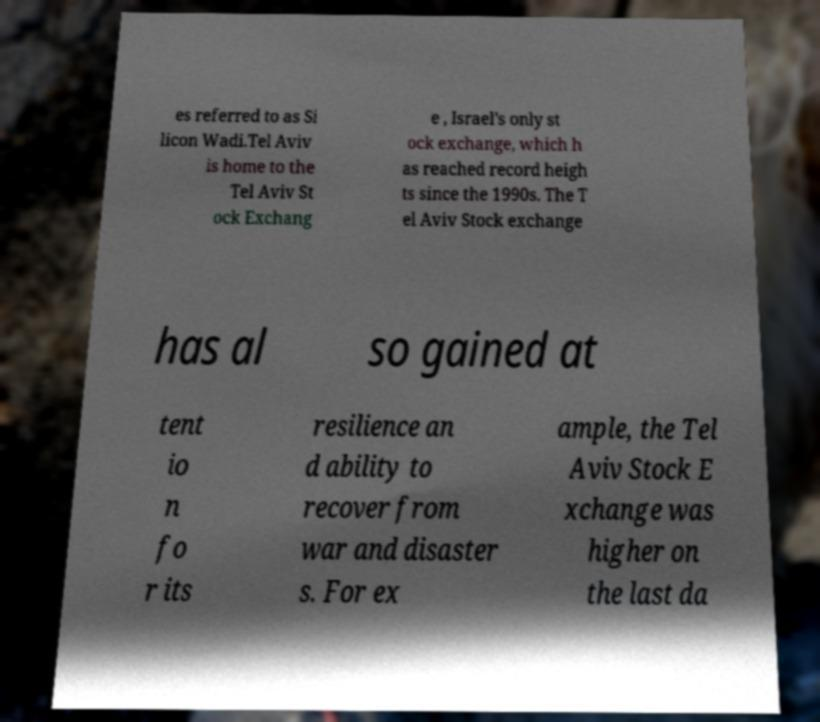Could you extract and type out the text from this image? es referred to as Si licon Wadi.Tel Aviv is home to the Tel Aviv St ock Exchang e , Israel's only st ock exchange, which h as reached record heigh ts since the 1990s. The T el Aviv Stock exchange has al so gained at tent io n fo r its resilience an d ability to recover from war and disaster s. For ex ample, the Tel Aviv Stock E xchange was higher on the last da 